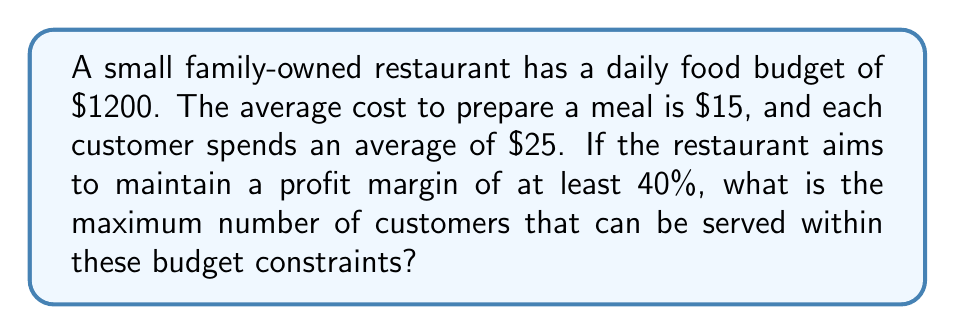Could you help me with this problem? Let's approach this step-by-step:

1) First, let's define our variables:
   $x$ = number of customers
   $C$ = cost per meal
   $R$ = revenue per customer
   $B$ = daily budget

2) We know:
   $C = $15
   $R = $25
   $B = $1200

3) The profit margin is calculated as:
   $\text{Profit Margin} = \frac{\text{Revenue} - \text{Cost}}{\text{Revenue}}$

4) We want this to be at least 40%, so:
   $$\frac{Rx - Cx}{Rx} \geq 0.40$$

5) Substituting known values:
   $$\frac{25x - 15x}{25x} \geq 0.40$$

6) Simplifying:
   $$\frac{10x}{25x} \geq 0.40$$
   $$0.40 \geq 0.40$$

   This inequality is always true, so we don't need to consider it further.

7) Now, we need to consider the budget constraint:
   $Cx \leq B$

8) Substituting known values:
   $15x \leq 1200$

9) Solving for $x$:
   $x \leq 80$

10) Therefore, the maximum number of customers that can be served within the budget is 80.

11) We should verify that this satisfies our profit margin requirement:
    Profit = $25 * 80 - $15 * 80 = $800
    Profit Margin = $800 / ($25 * 80) = 0.40 or 40%

    This confirms that serving 80 customers meets the profit margin requirement.
Answer: 80 customers 